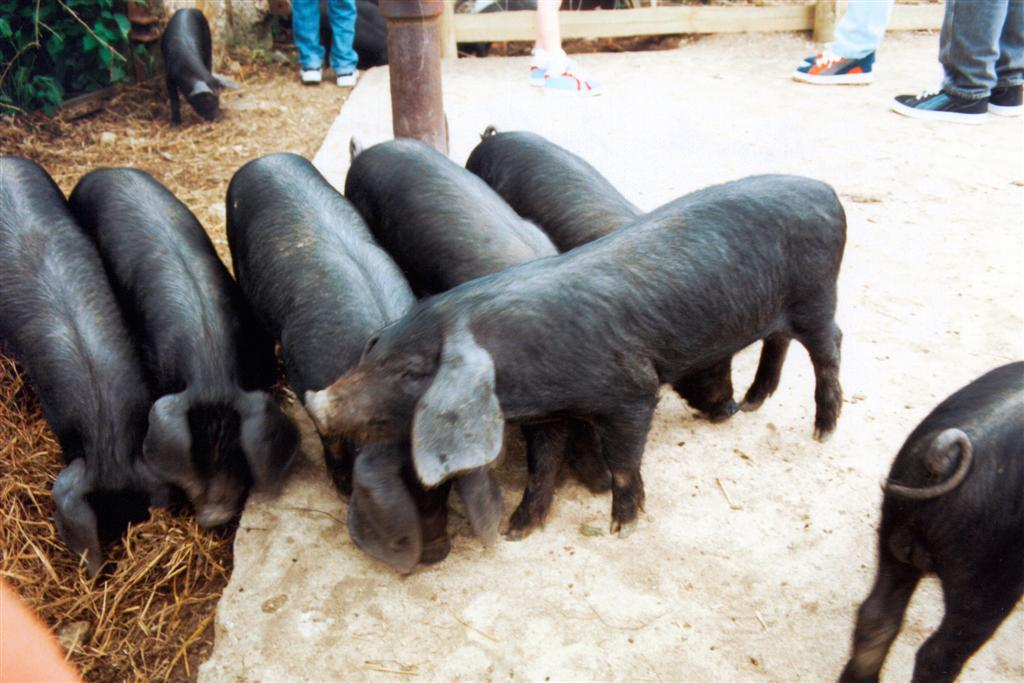What animals are on the floor in the image? There are pigs on the floor in the image. What type of vegetation is present in the image? There is grass in the image. Are there any plants visible in the image? Yes, there is a plant in the image. Can you describe the people in the image? There are other people in the image. What color is the brain of the pig in the image? There is no brain visible in the image, as it focuses on the pigs on the floor and other elements. 